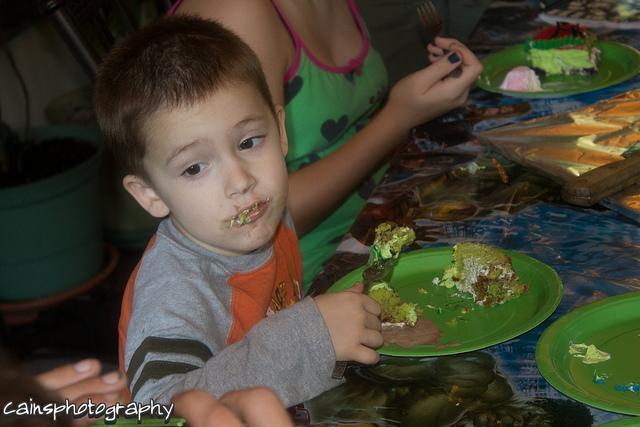If the boy overeats he will get what kind of body ache?
Answer the question by selecting the correct answer among the 4 following choices.
Options: Ear, eye, stomach, back. Stomach. 